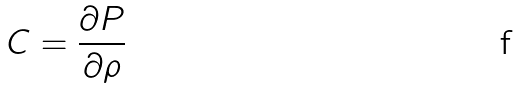<formula> <loc_0><loc_0><loc_500><loc_500>C = \frac { \partial P } { \partial \rho }</formula> 